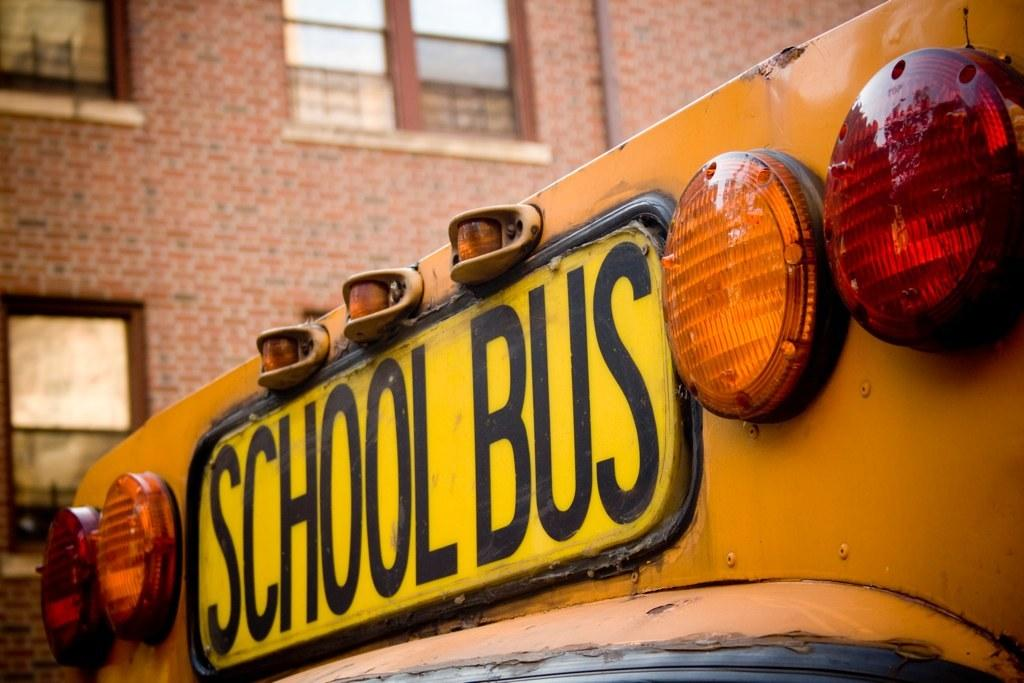What type of building is in the image? There is a big building with glass windows in the image. What is located in front of the building? There is a school bus in front of the building. What can be seen on the school bus? The school bus has some text and lights on it. What type of flesh can be seen hanging from the school bus in the image? There is no flesh present in the image; it features a big building and a school bus with text and lights. 